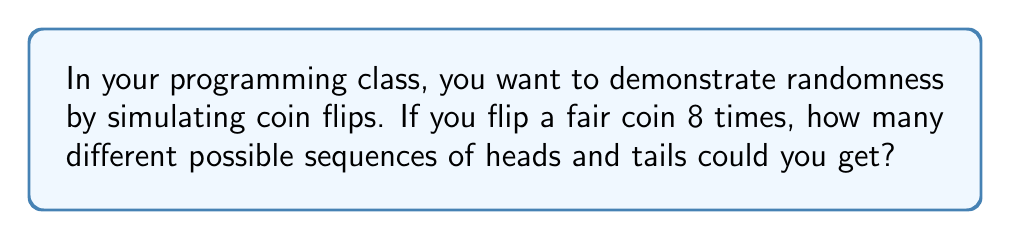Teach me how to tackle this problem. Let's approach this step-by-step:

1) For each individual coin flip, there are 2 possible outcomes: heads (H) or tails (T).

2) We are performing 8 independent coin flips. For each flip, the outcome doesn't depend on the previous flips.

3) This scenario follows the multiplication principle of counting. When we have a sequence of independent events, we multiply the number of possibilities for each event.

4) In this case, we have:
   $$2 \times 2 \times 2 \times 2 \times 2 \times 2 \times 2 \times 2$$

5) This is equivalent to $2^8$, because we're multiplying 2 by itself 8 times.

6) We can calculate this:
   $$2^8 = 2 \times 2 \times 2 \times 2 \times 2 \times 2 \times 2 \times 2 = 256$$

Therefore, there are 256 different possible sequences of heads and tails when flipping a coin 8 times.

This concept can be used in programming to generate random sequences, which could be a practical application in your coding class.
Answer: $256$ 